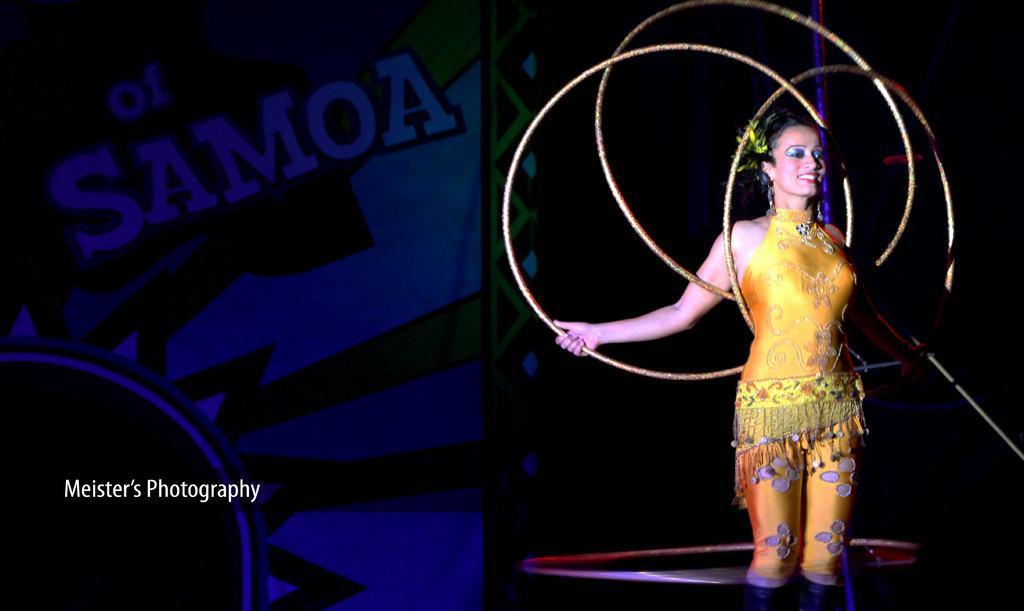In one or two sentences, can you explain what this image depicts? On the right side of the image, we can see a woman is holding some rings and smiling. Background we can see a banner. Left side of the image, we can see a text. 